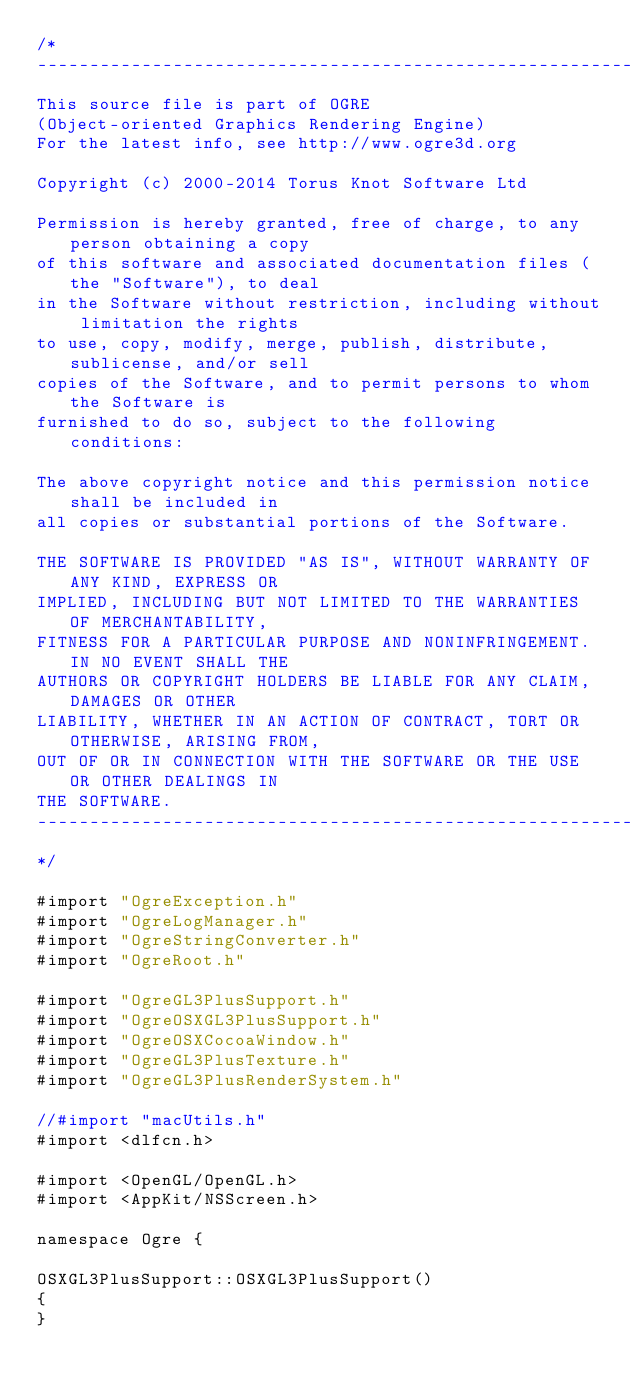<code> <loc_0><loc_0><loc_500><loc_500><_ObjectiveC_>/*
-----------------------------------------------------------------------------
This source file is part of OGRE
(Object-oriented Graphics Rendering Engine)
For the latest info, see http://www.ogre3d.org

Copyright (c) 2000-2014 Torus Knot Software Ltd

Permission is hereby granted, free of charge, to any person obtaining a copy
of this software and associated documentation files (the "Software"), to deal
in the Software without restriction, including without limitation the rights
to use, copy, modify, merge, publish, distribute, sublicense, and/or sell
copies of the Software, and to permit persons to whom the Software is
furnished to do so, subject to the following conditions:

The above copyright notice and this permission notice shall be included in
all copies or substantial portions of the Software.

THE SOFTWARE IS PROVIDED "AS IS", WITHOUT WARRANTY OF ANY KIND, EXPRESS OR
IMPLIED, INCLUDING BUT NOT LIMITED TO THE WARRANTIES OF MERCHANTABILITY,
FITNESS FOR A PARTICULAR PURPOSE AND NONINFRINGEMENT. IN NO EVENT SHALL THE
AUTHORS OR COPYRIGHT HOLDERS BE LIABLE FOR ANY CLAIM, DAMAGES OR OTHER
LIABILITY, WHETHER IN AN ACTION OF CONTRACT, TORT OR OTHERWISE, ARISING FROM,
OUT OF OR IN CONNECTION WITH THE SOFTWARE OR THE USE OR OTHER DEALINGS IN
THE SOFTWARE.
-----------------------------------------------------------------------------
*/

#import "OgreException.h"
#import "OgreLogManager.h"
#import "OgreStringConverter.h"
#import "OgreRoot.h"

#import "OgreGL3PlusSupport.h"
#import "OgreOSXGL3PlusSupport.h"
#import "OgreOSXCocoaWindow.h"
#import "OgreGL3PlusTexture.h"
#import "OgreGL3PlusRenderSystem.h"

//#import "macUtils.h"
#import <dlfcn.h>

#import <OpenGL/OpenGL.h>
#import <AppKit/NSScreen.h>

namespace Ogre {

OSXGL3PlusSupport::OSXGL3PlusSupport()
{
}
</code> 